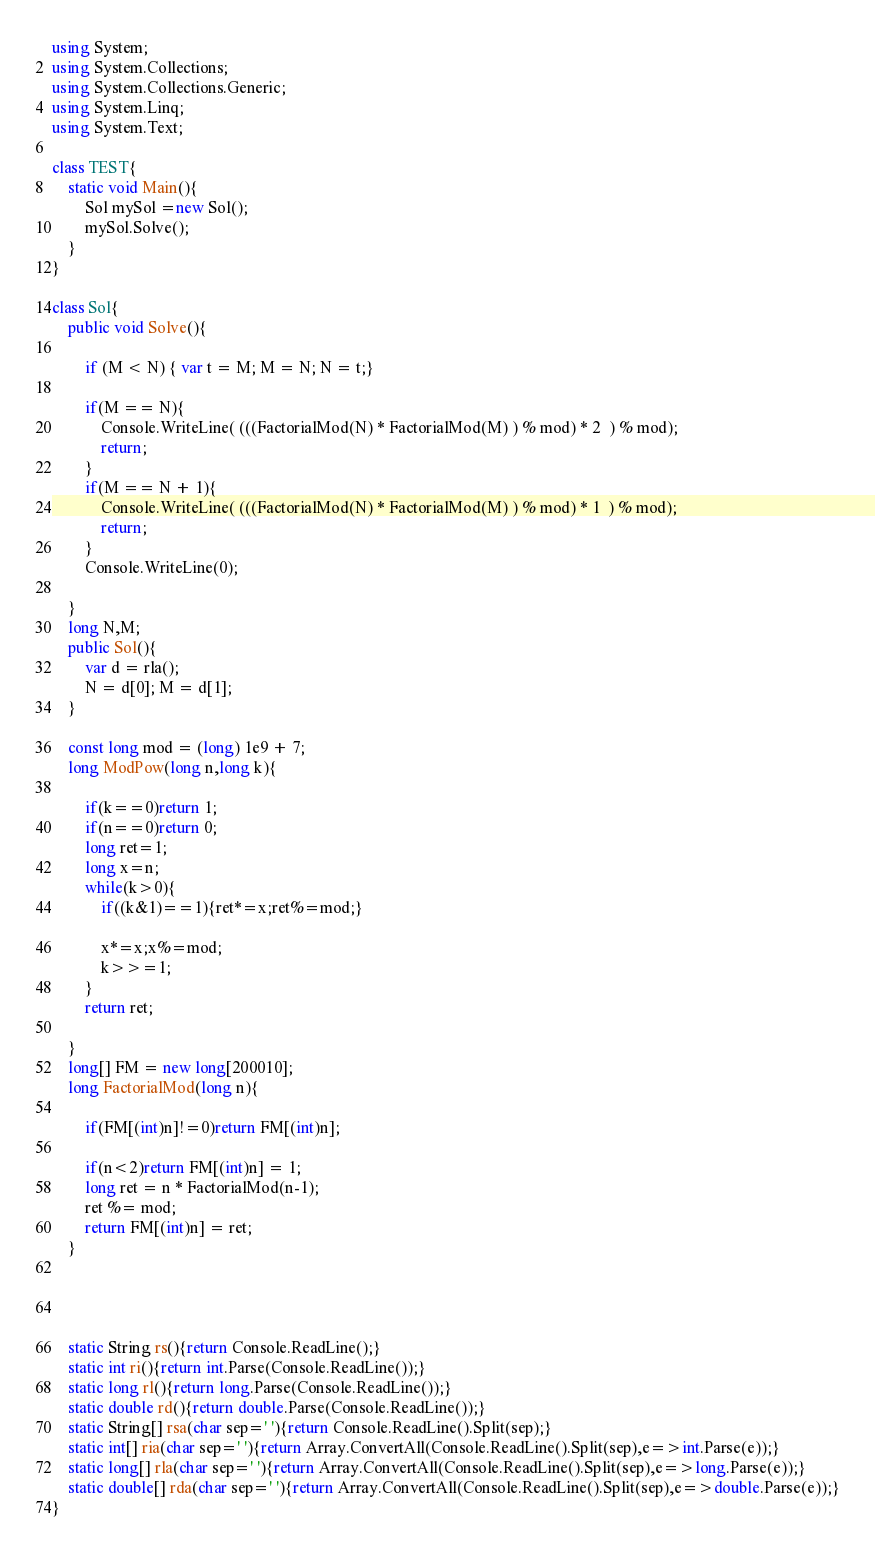Convert code to text. <code><loc_0><loc_0><loc_500><loc_500><_C#_>using System;
using System.Collections;
using System.Collections.Generic;
using System.Linq;
using System.Text;

class TEST{
	static void Main(){
		Sol mySol =new Sol();
		mySol.Solve();
	}
}

class Sol{
	public void Solve(){
		
		if (M < N) { var t = M; M = N; N = t;}
		
		if(M == N){
			Console.WriteLine( (((FactorialMod(N) * FactorialMod(M) ) % mod) * 2  ) % mod);
			return; 
		}
		if(M == N + 1){
			Console.WriteLine( (((FactorialMod(N) * FactorialMod(M) ) % mod) * 1  ) % mod);
			return; 
		}
		Console.WriteLine(0);
		
	}
	long N,M;
	public Sol(){
		var d = rla();
		N = d[0]; M = d[1];
	}
	
	const long mod = (long) 1e9 + 7;
	long ModPow(long n,long k){
		
		if(k==0)return 1;
		if(n==0)return 0;
		long ret=1;
		long x=n;
		while(k>0){
			if((k&1)==1){ret*=x;ret%=mod;}
			
			x*=x;x%=mod;
			k>>=1;
		}
		return ret;
		
	}
	long[] FM = new long[200010];
	long FactorialMod(long n){
		
		if(FM[(int)n]!=0)return FM[(int)n];

		if(n<2)return FM[(int)n] = 1;
		long ret = n * FactorialMod(n-1);
		ret %= mod;
		return FM[(int)n] = ret;
	}
	
	
	

	static String rs(){return Console.ReadLine();}
	static int ri(){return int.Parse(Console.ReadLine());}
	static long rl(){return long.Parse(Console.ReadLine());}
	static double rd(){return double.Parse(Console.ReadLine());}
	static String[] rsa(char sep=' '){return Console.ReadLine().Split(sep);}
	static int[] ria(char sep=' '){return Array.ConvertAll(Console.ReadLine().Split(sep),e=>int.Parse(e));}
	static long[] rla(char sep=' '){return Array.ConvertAll(Console.ReadLine().Split(sep),e=>long.Parse(e));}
	static double[] rda(char sep=' '){return Array.ConvertAll(Console.ReadLine().Split(sep),e=>double.Parse(e));}
}
</code> 